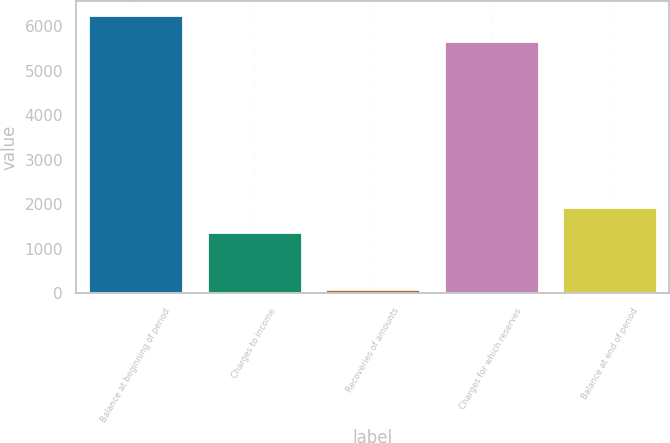Convert chart. <chart><loc_0><loc_0><loc_500><loc_500><bar_chart><fcel>Balance at beginning of period<fcel>Charges to income<fcel>Recoveries of amounts<fcel>Charges for which reserves<fcel>Balance at end of period<nl><fcel>6248.3<fcel>1365<fcel>107<fcel>5670<fcel>1943.3<nl></chart> 